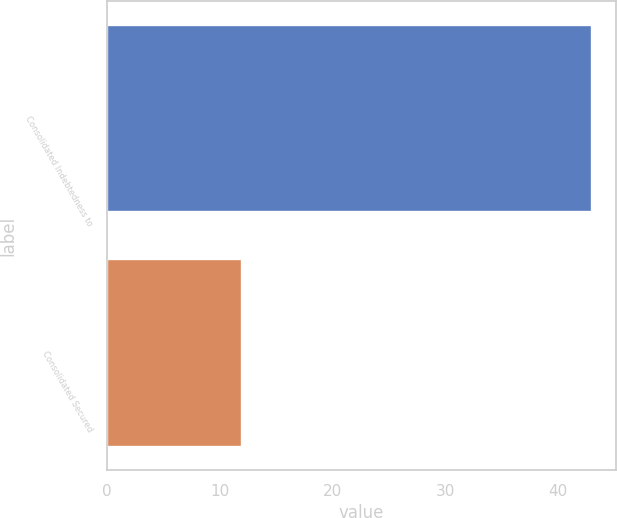Convert chart. <chart><loc_0><loc_0><loc_500><loc_500><bar_chart><fcel>Consolidated Indebtedness to<fcel>Consolidated Secured<nl><fcel>43<fcel>12<nl></chart> 